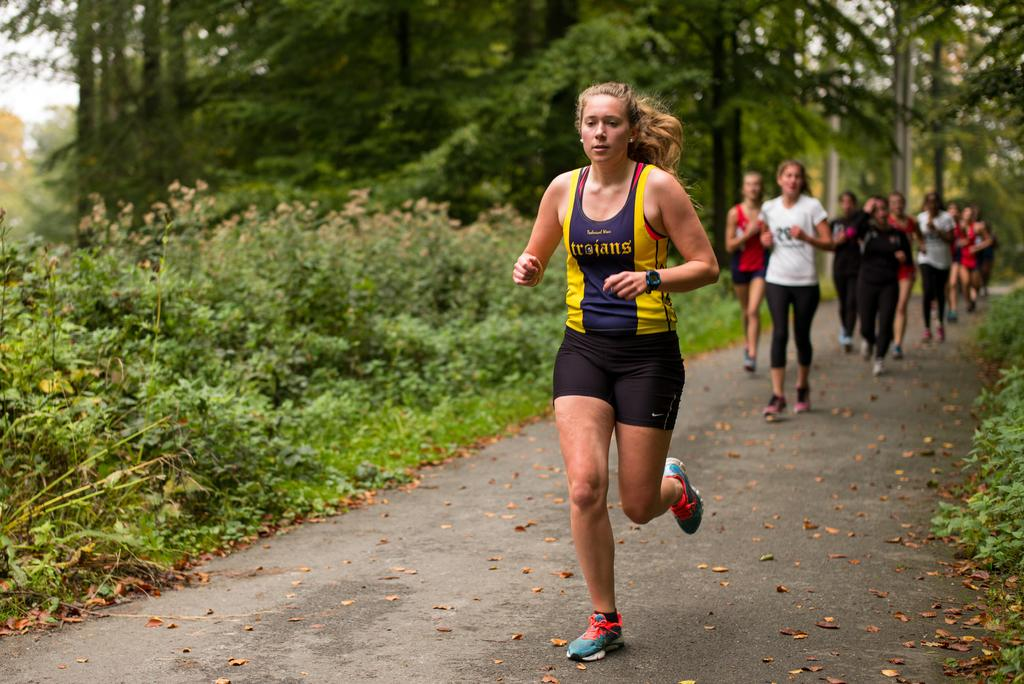What are the persons in the image doing? The persons in the image are jogging. Where are the persons jogging? The persons are jogging on a road. What can be seen on both sides of the road? There are many trees on both sides of the road. What type of railway can be seen in the image? There is no railway present in the image; it features persons jogging on a road with trees on both sides. How many rabbits are visible in the image? There are no rabbits visible in the image. 